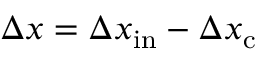Convert formula to latex. <formula><loc_0><loc_0><loc_500><loc_500>\Delta x = \Delta x _ { i n } - \Delta x _ { c }</formula> 